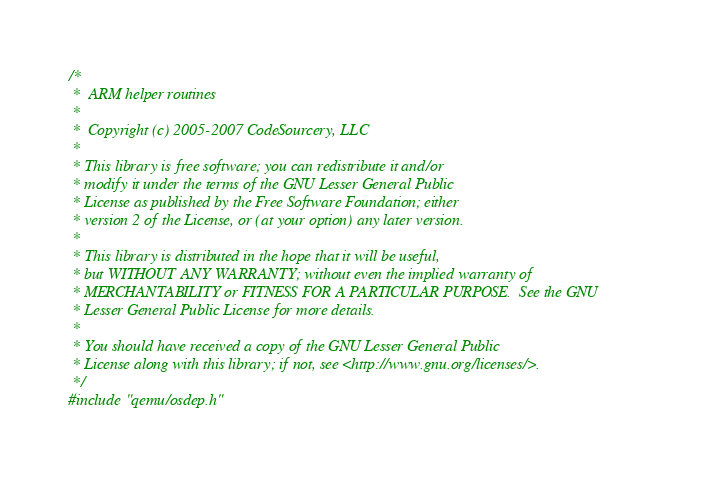<code> <loc_0><loc_0><loc_500><loc_500><_C_>/*
 *  ARM helper routines
 *
 *  Copyright (c) 2005-2007 CodeSourcery, LLC
 *
 * This library is free software; you can redistribute it and/or
 * modify it under the terms of the GNU Lesser General Public
 * License as published by the Free Software Foundation; either
 * version 2 of the License, or (at your option) any later version.
 *
 * This library is distributed in the hope that it will be useful,
 * but WITHOUT ANY WARRANTY; without even the implied warranty of
 * MERCHANTABILITY or FITNESS FOR A PARTICULAR PURPOSE.  See the GNU
 * Lesser General Public License for more details.
 *
 * You should have received a copy of the GNU Lesser General Public
 * License along with this library; if not, see <http://www.gnu.org/licenses/>.
 */
#include "qemu/osdep.h"</code> 